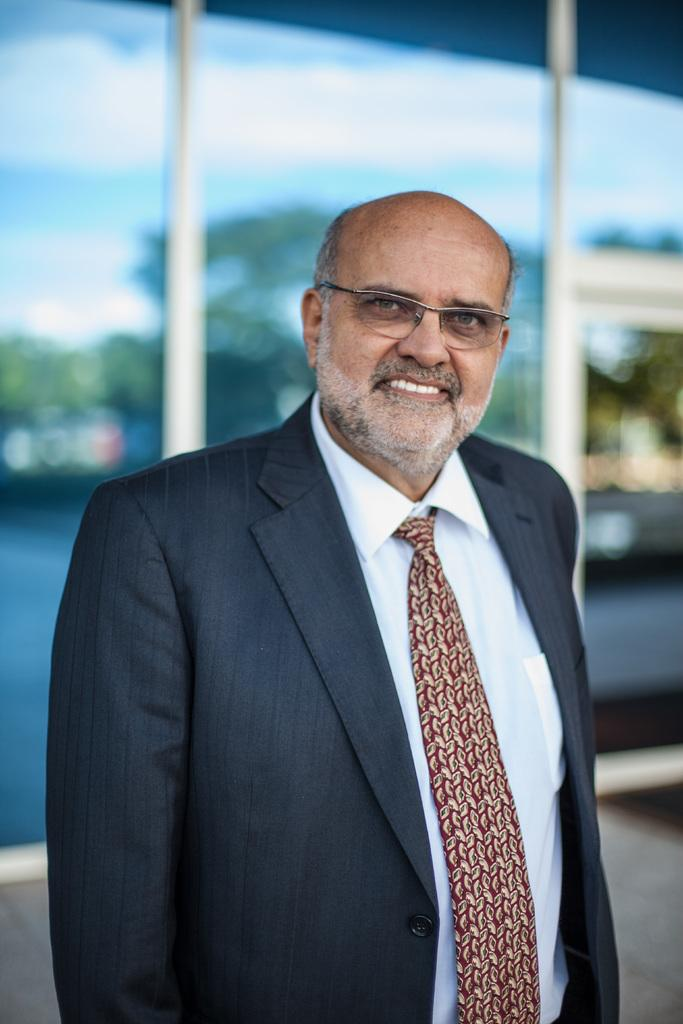Who is present in the image? There is a man in the image. What is the man doing in the image? The man is smiling in the image. What accessory is the man wearing? The man is wearing spectacles in the image. Can you describe the background of the image? The background of the image is blurred. What type of furniture can be seen in the image? There are tables in the image. What objects are present on the tables? Glasses are present in the image. What can be seen in the reflection on the glasses? Trees and sky are visible in the reflection on the glasses. What type of paper is the snail using to write a letter in the image? There is no snail or paper present in the image. How many scissors are visible on the tables in the image? There is no mention of scissors in the image, so we cannot determine how many are present. 